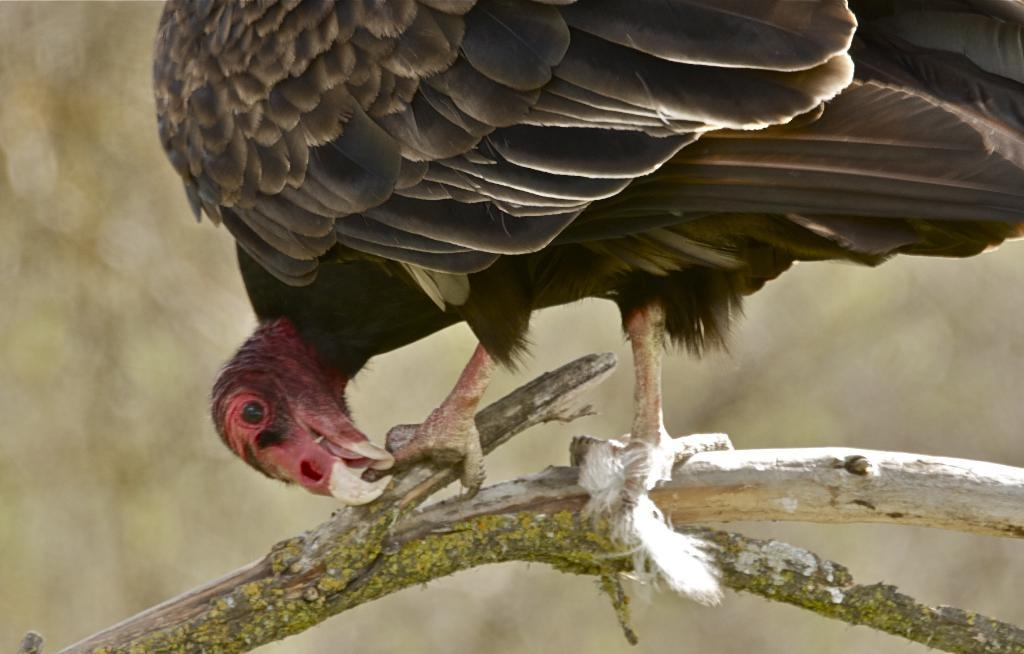What type of animal is in the image? There is a bird in the image. Where is the bird located? The bird is standing on a branch of a tree. Can you describe the background of the image? The background of the image is blurry. What type of toys can be seen on top of the bird in the image? There are no toys present in the image, and the bird is not on top of anything. 